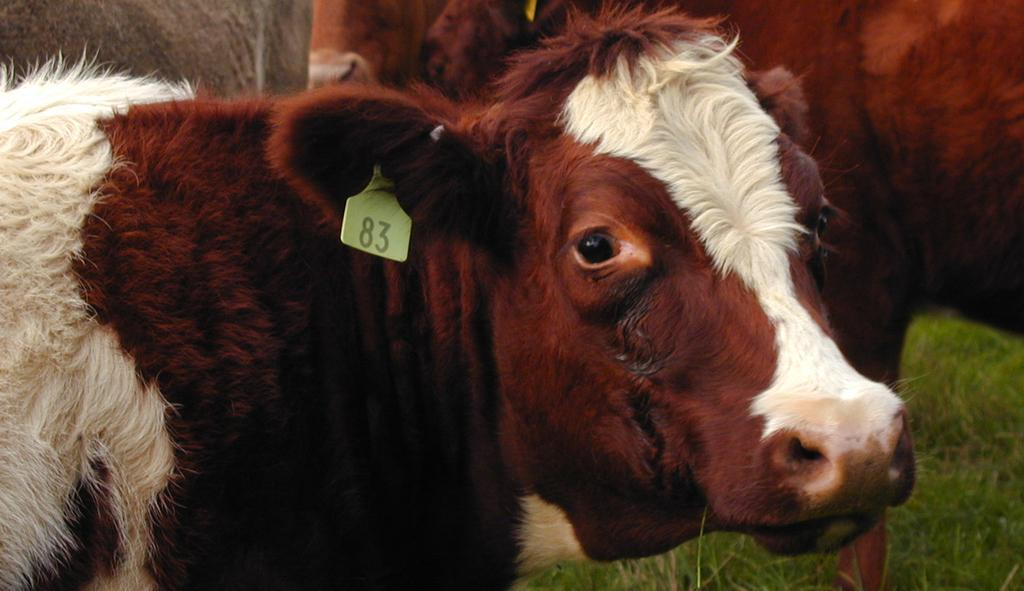What type of animals are present in the image? There are cattle in the image. Where are the cattle located in the image? The cattle are standing on the ground. What type of breakfast is the cattle eating in the image? There is no breakfast present in the image; it only features cattle standing on the ground. 